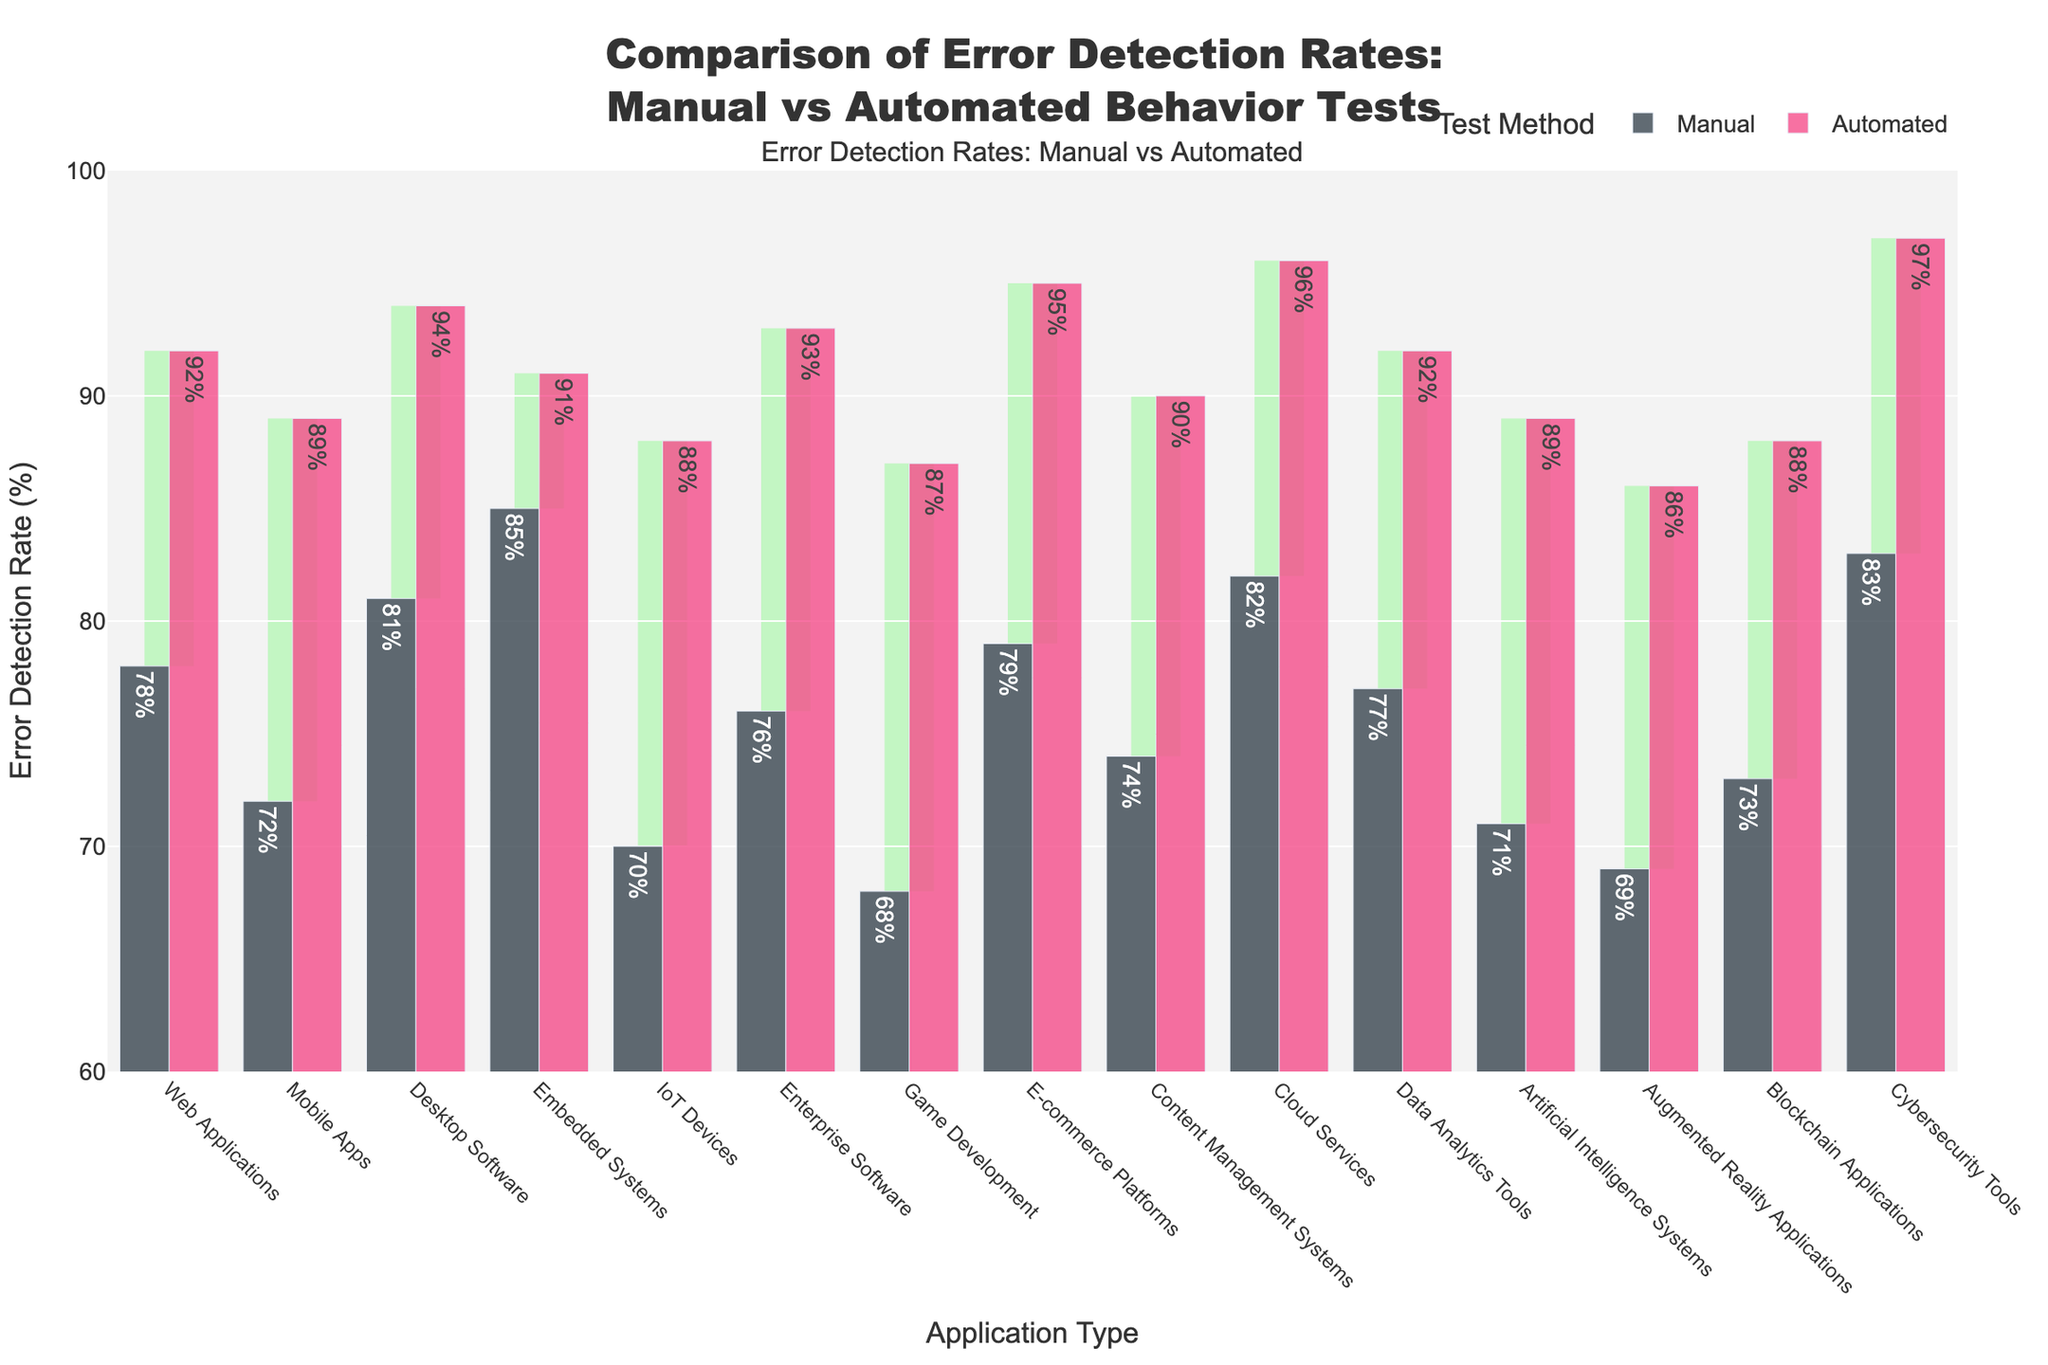What is the difference in error detection rates between manual and automated tests for Cloud Services? To find the difference, subtract the Manual Error Detection Rate from the Automated Error Detection Rate for Cloud Services: 96% - 82% = 14%.
Answer: 14% Which application type shows the smallest absolute difference between manual and automated error detection rates? Calculate the absolute difference for each application type and compare them. Embedded Systems have an absolute difference of abs(91 - 85) = 6, which is the smallest.
Answer: Embedded Systems Which application type has the highest automated error detection rate? From the bar chart, identify the application type with the tallest bar for automated error detection rates. Cybersecurity Tools has the highest rate at 97%.
Answer: Cybersecurity Tools What is the average automated error detection rate across all application types? Sum the automated error detection rates for all application types, then divide by the number of application types: (92 + 89 + 94 + 91 + 88 + 93 + 87 + 95 + 90 + 96 + 92 + 89 + 86 + 88 + 97)/15 = 91.2%.
Answer: 91.2% How many application types have an automated error detection rate of 90% or higher? Count the bars representing automated error detection rates that are 90% or higher: Web Applications, Desktop Software, Embedded Systems, Enterprise Software, E-commerce Platforms, Cloud Services, Cybersecurity Tools. There are 7 such application types.
Answer: 7 Compare the error detection rates for Manual and Automated tests in E-commerce Platforms. Which one is higher, and by how much? The error detection rates for E-commerce Platforms are 79% (Manual) and 95% (Automated). Automated is higher by 95% - 79% = 16%.
Answer: Automated, 16% Which application type has the lowest manual error detection rate, and what is that rate? From the bar chart, identify the application type with the shortest bar for manual error detection rates. Game Development has the lowest rate at 68%.
Answer: Game Development, 68% 